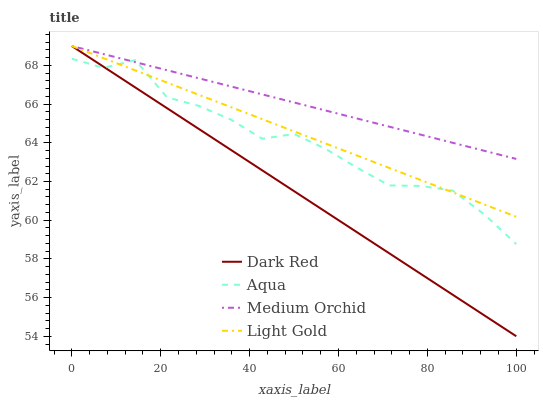Does Dark Red have the minimum area under the curve?
Answer yes or no. Yes. Does Medium Orchid have the maximum area under the curve?
Answer yes or no. Yes. Does Aqua have the minimum area under the curve?
Answer yes or no. No. Does Aqua have the maximum area under the curve?
Answer yes or no. No. Is Dark Red the smoothest?
Answer yes or no. Yes. Is Aqua the roughest?
Answer yes or no. Yes. Is Medium Orchid the smoothest?
Answer yes or no. No. Is Medium Orchid the roughest?
Answer yes or no. No. Does Dark Red have the lowest value?
Answer yes or no. Yes. Does Aqua have the lowest value?
Answer yes or no. No. Does Light Gold have the highest value?
Answer yes or no. Yes. Does Aqua have the highest value?
Answer yes or no. No. Does Light Gold intersect Medium Orchid?
Answer yes or no. Yes. Is Light Gold less than Medium Orchid?
Answer yes or no. No. Is Light Gold greater than Medium Orchid?
Answer yes or no. No. 